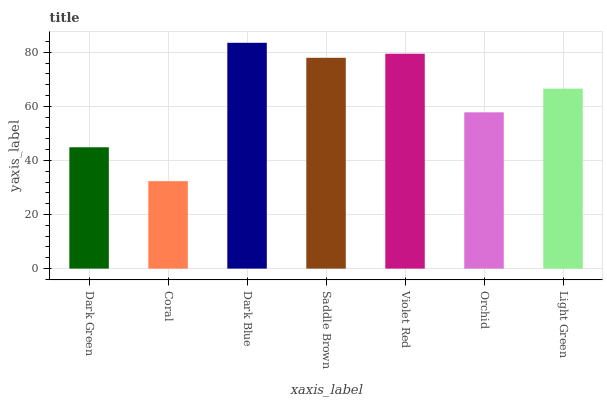Is Coral the minimum?
Answer yes or no. Yes. Is Dark Blue the maximum?
Answer yes or no. Yes. Is Dark Blue the minimum?
Answer yes or no. No. Is Coral the maximum?
Answer yes or no. No. Is Dark Blue greater than Coral?
Answer yes or no. Yes. Is Coral less than Dark Blue?
Answer yes or no. Yes. Is Coral greater than Dark Blue?
Answer yes or no. No. Is Dark Blue less than Coral?
Answer yes or no. No. Is Light Green the high median?
Answer yes or no. Yes. Is Light Green the low median?
Answer yes or no. Yes. Is Coral the high median?
Answer yes or no. No. Is Dark Green the low median?
Answer yes or no. No. 